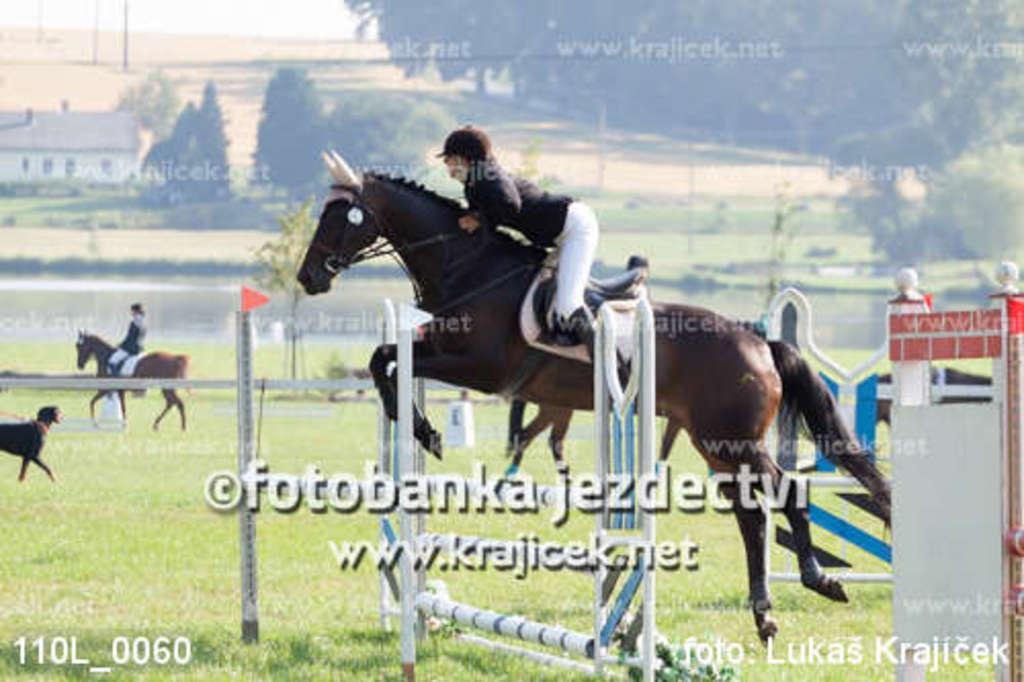Could you give a brief overview of what you see in this image? In this image I can see a person wearing black dress, white pant and hat is sitting on a horse which is black and brown in color. I can see few metal poles, some grass, a flag, a dog and another person sitting on the horse. In the background I can see few trees, the ground, a building and the sky. 